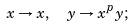<formula> <loc_0><loc_0><loc_500><loc_500>x \rightarrow x , \ \ y \rightarrow x ^ { p } y ;</formula> 